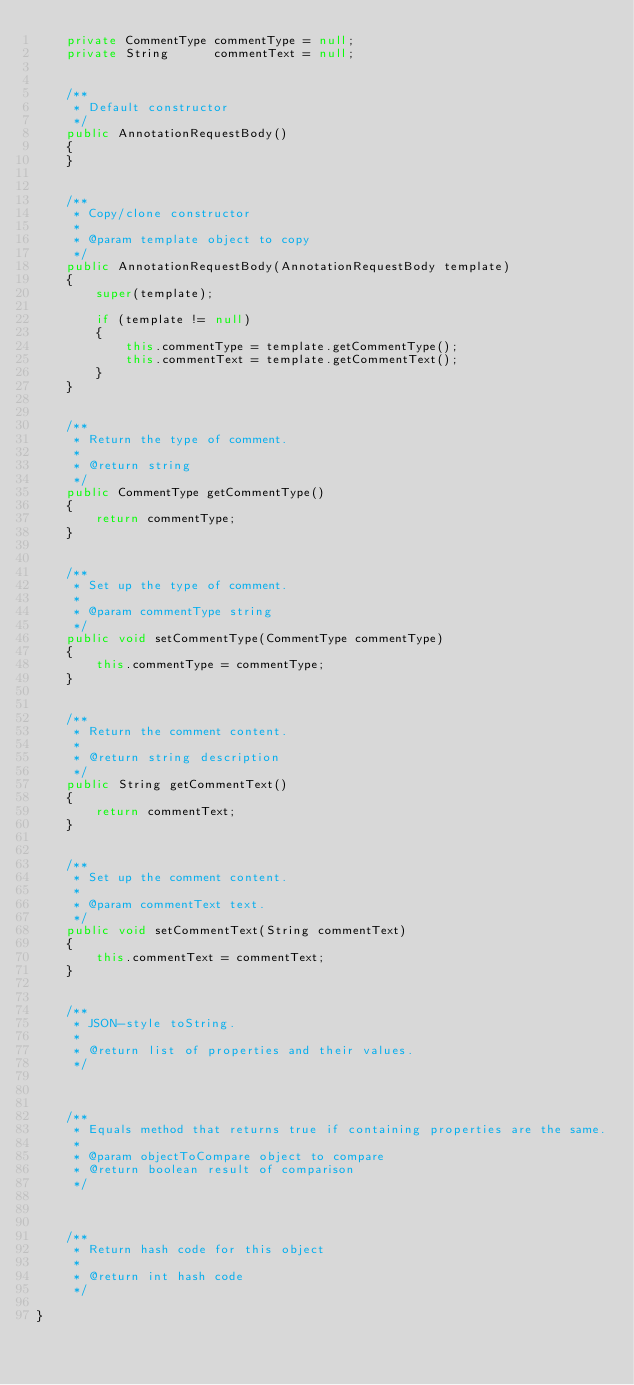<code> <loc_0><loc_0><loc_500><loc_500><_Java_>    private CommentType commentType = null;
    private String      commentText = null;


    /**
     * Default constructor
     */
    public AnnotationRequestBody()
    {
    }


    /**
     * Copy/clone constructor
     *
     * @param template object to copy
     */
    public AnnotationRequestBody(AnnotationRequestBody template)
    {
        super(template);

        if (template != null)
        {
            this.commentType = template.getCommentType();
            this.commentText = template.getCommentText();
        }
    }
    

    /**
     * Return the type of comment.
     * 
     * @return string
     */
    public CommentType getCommentType()
    {
        return commentType;
    }


    /**
     * Set up the type of comment.
     * 
     * @param commentType string
     */
    public void setCommentType(CommentType commentType)
    {
        this.commentType = commentType;
    }


    /**
     * Return the comment content.
     * 
     * @return string description
     */
    public String getCommentText()
    {
        return commentText;
    }


    /**
     * Set up the comment content.
     * 
     * @param commentText text.
     */
    public void setCommentText(String commentText)
    {
        this.commentText = commentText;
    }


    /**
     * JSON-style toString.
     *
     * @return list of properties and their values.
     */



    /**
     * Equals method that returns true if containing properties are the same.
     *
     * @param objectToCompare object to compare
     * @return boolean result of comparison
     */



    /**
     * Return hash code for this object
     *
     * @return int hash code
     */

}
</code> 